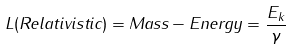<formula> <loc_0><loc_0><loc_500><loc_500>L ( R e l a t i v i s t i c ) = M a s s - E n e r g y = \frac { E _ { k } } { \gamma }</formula> 